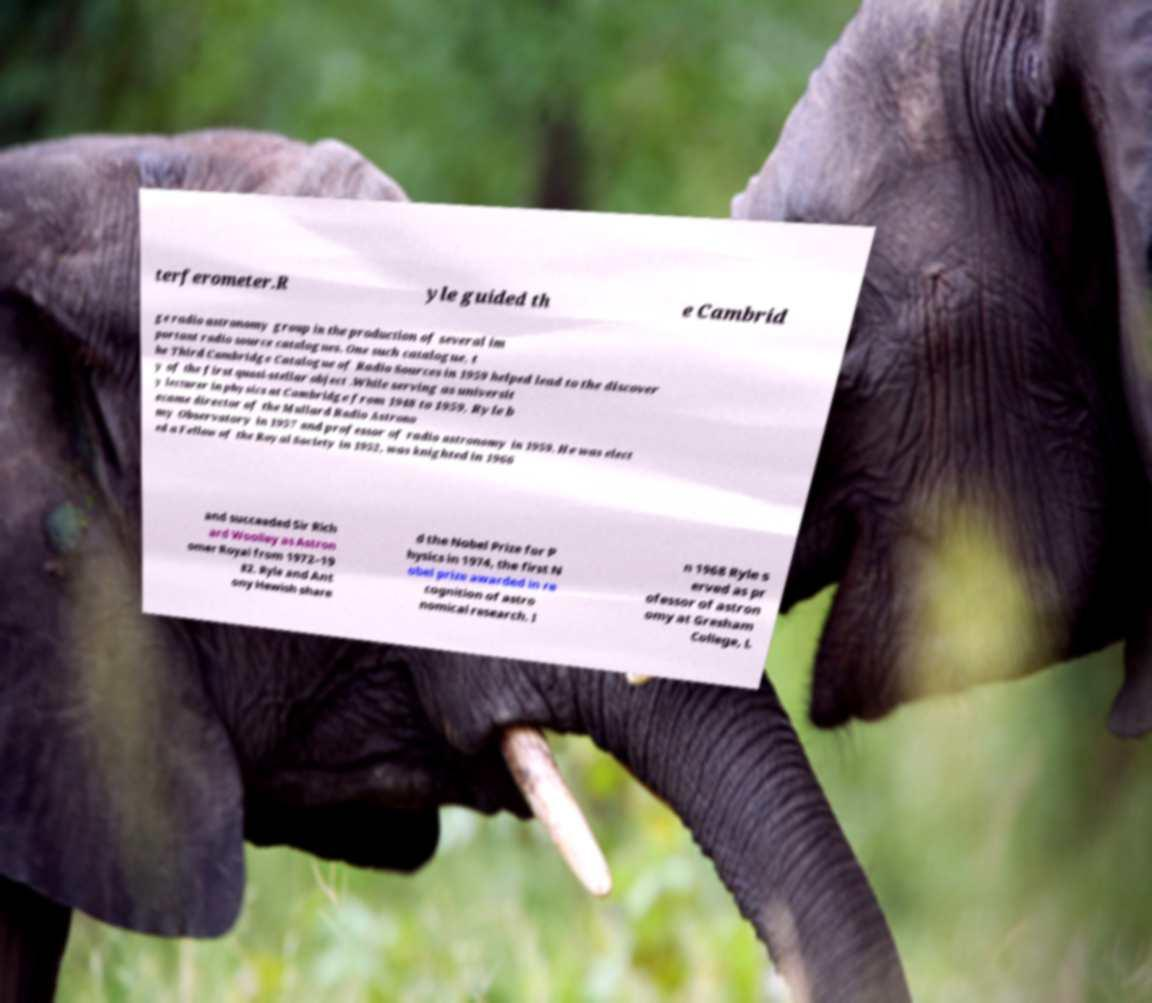There's text embedded in this image that I need extracted. Can you transcribe it verbatim? terferometer.R yle guided th e Cambrid ge radio astronomy group in the production of several im portant radio source catalogues. One such catalogue, t he Third Cambridge Catalogue of Radio Sources in 1959 helped lead to the discover y of the first quasi-stellar object .While serving as universit y lecturer in physics at Cambridge from 1948 to 1959, Ryle b ecame director of the Mullard Radio Astrono my Observatory in 1957 and professor of radio astronomy in 1959. He was elect ed a Fellow of the Royal Society in 1952, was knighted in 1966 and succeeded Sir Rich ard Woolley as Astron omer Royal from 1972–19 82. Ryle and Ant ony Hewish share d the Nobel Prize for P hysics in 1974, the first N obel prize awarded in re cognition of astro nomical research. I n 1968 Ryle s erved as pr ofessor of astron omy at Gresham College, L 